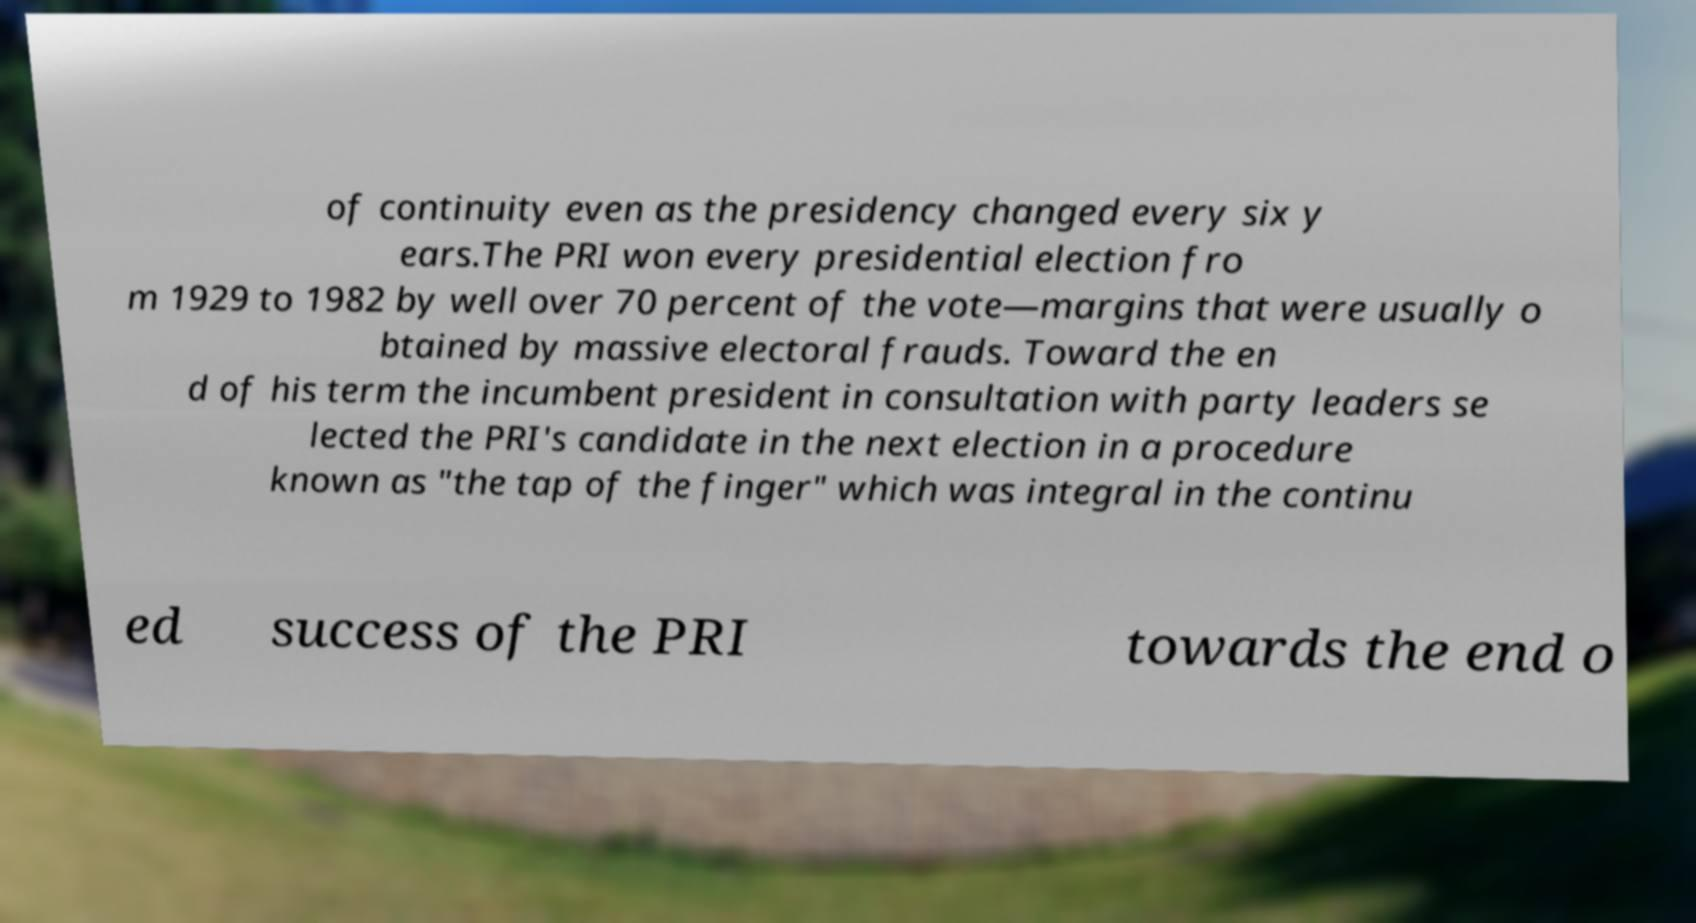What messages or text are displayed in this image? I need them in a readable, typed format. of continuity even as the presidency changed every six y ears.The PRI won every presidential election fro m 1929 to 1982 by well over 70 percent of the vote—margins that were usually o btained by massive electoral frauds. Toward the en d of his term the incumbent president in consultation with party leaders se lected the PRI's candidate in the next election in a procedure known as "the tap of the finger" which was integral in the continu ed success of the PRI towards the end o 